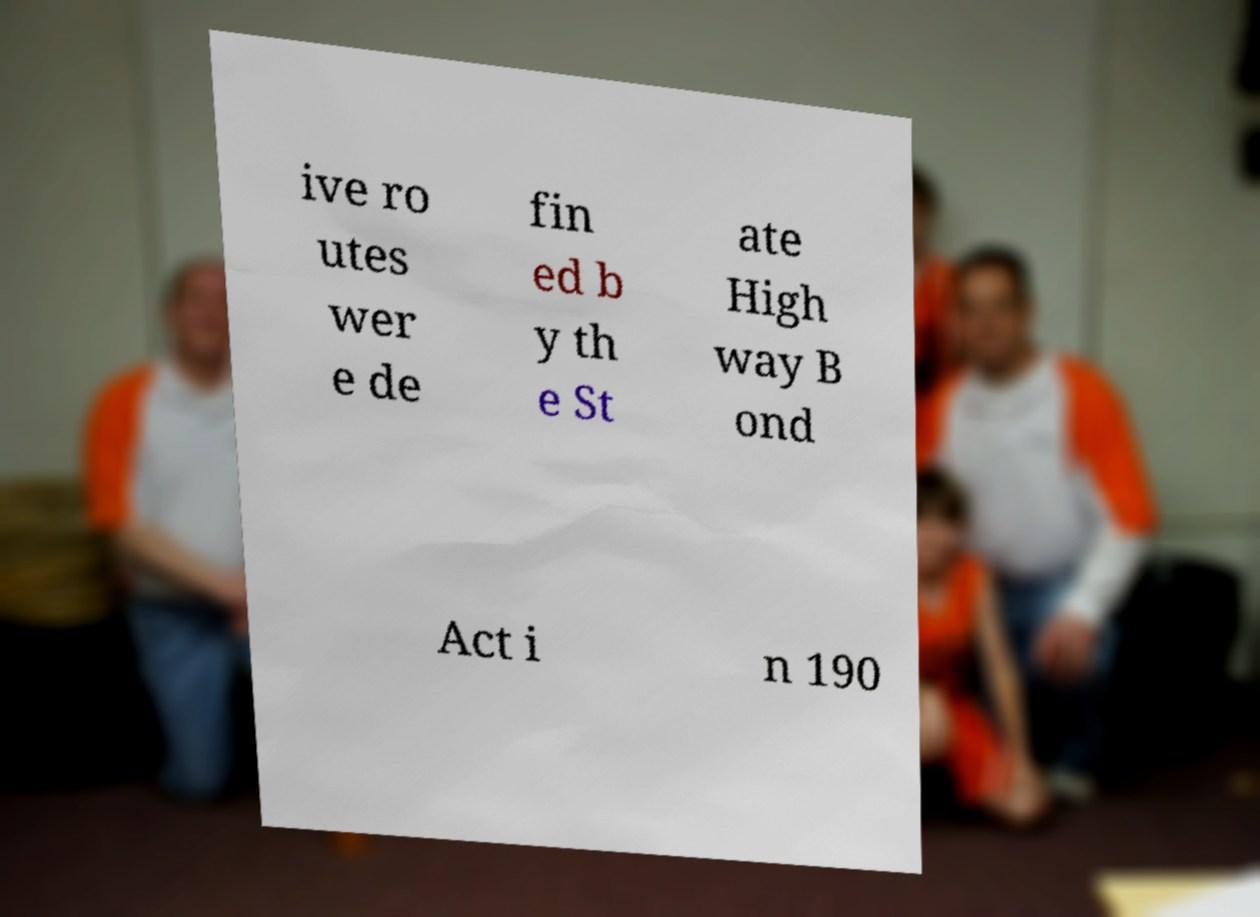What messages or text are displayed in this image? I need them in a readable, typed format. ive ro utes wer e de fin ed b y th e St ate High way B ond Act i n 190 